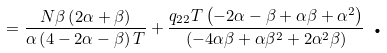Convert formula to latex. <formula><loc_0><loc_0><loc_500><loc_500>= \frac { N \beta \left ( 2 \alpha + \beta \right ) } { \alpha \left ( 4 - 2 \alpha - \beta \right ) T } + \frac { q _ { 2 2 } T \left ( - 2 \alpha - \beta + \alpha \beta + \alpha ^ { 2 } \right ) } { \left ( - 4 \alpha \beta + \alpha \beta ^ { 2 } + 2 \alpha ^ { 2 } \beta \right ) } \text { .}</formula> 